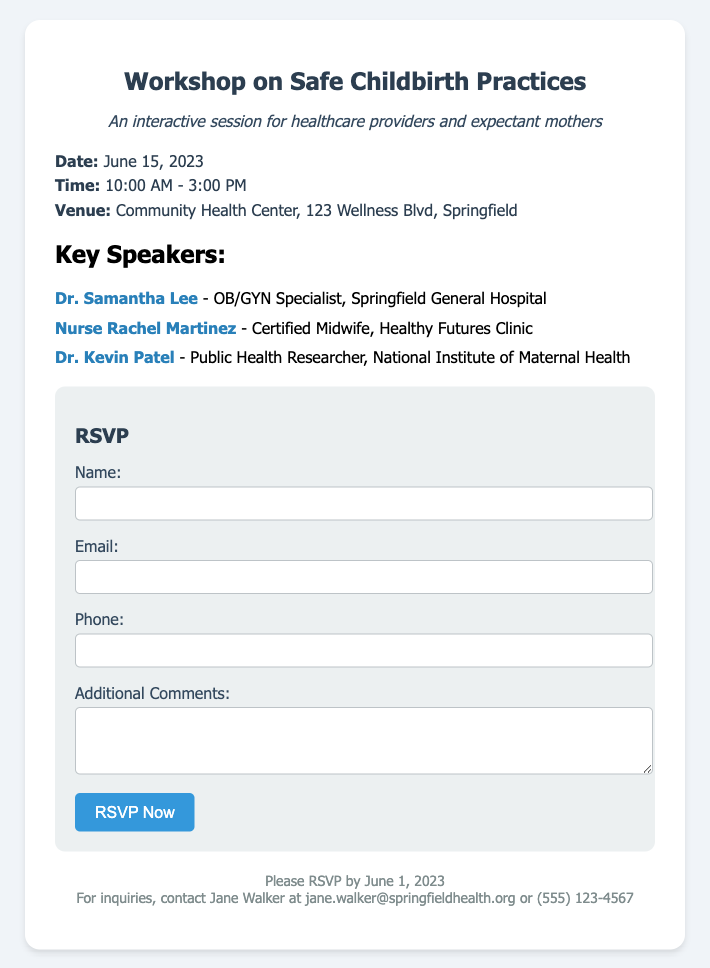What is the date of the workshop? The date of the workshop is explicitly mentioned in the document.
Answer: June 15, 2023 Who is the OB/GYN specialist speaking at the workshop? The document lists the key speakers, including their titles and affiliations.
Answer: Dr. Samantha Lee What time does the workshop start? The starting time of the workshop is specified in the details section of the document.
Answer: 10:00 AM Where will the workshop be held? The venue for the workshop is provided in the document's details section.
Answer: Community Health Center, 123 Wellness Blvd, Springfield What is the RSVP deadline? The document includes a note regarding when to RSVP for the event.
Answer: June 1, 2023 How many speakers are listed? The number of speakers is determined by counting the entries in the speakers section of the document.
Answer: Three Who should inquiries be directed to? The document specifies a contact person for inquiries related to the workshop.
Answer: Jane Walker What type of session is the workshop described as? The document includes a subtitle that describes the nature of the event.
Answer: Interactive session 